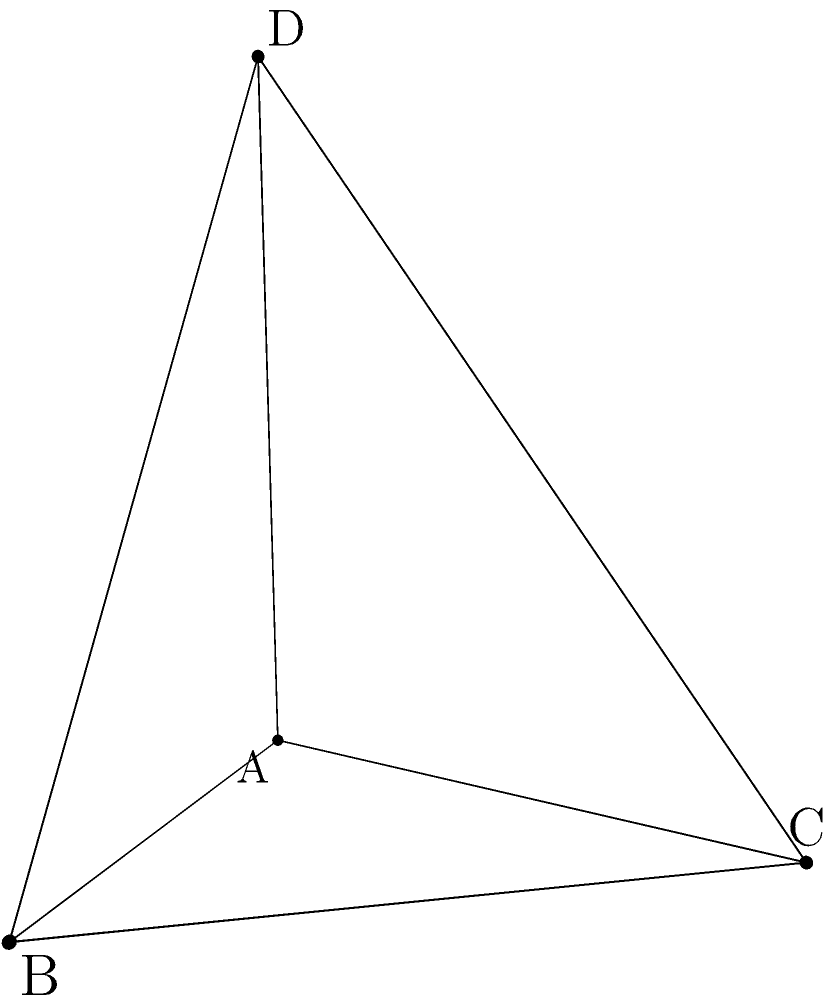Hey there! Remember those challenging geometry problems we used to solve back in university? Here's one that reminds me of our study sessions. Given a tetrahedron ABCD with vertices A(0,0,0), B(3,0,0), C(0,4,0), and D(0,0,5), calculate its volume. Let's approach this step-by-step:

1) The volume of a tetrahedron can be calculated using the formula:

   $$V = \frac{1}{6}|det(\vec{AB}, \vec{AC}, \vec{AD})|$$

   where $\vec{AB}$, $\vec{AC}$, and $\vec{AD}$ are vectors.

2) Let's find these vectors:
   $\vec{AB} = B - A = (3,0,0) - (0,0,0) = (3,0,0)$
   $\vec{AC} = C - A = (0,4,0) - (0,0,0) = (0,4,0)$
   $\vec{AD} = D - A = (0,0,5) - (0,0,0) = (0,0,5)$

3) Now, let's set up the determinant:

   $$det = \begin{vmatrix} 
   3 & 0 & 0 \\
   0 & 4 & 0 \\
   0 & 0 & 5
   \end{vmatrix}$$

4) Calculate the determinant:
   $det = 3 \cdot 4 \cdot 5 = 60$

5) Finally, apply the volume formula:

   $$V = \frac{1}{6}|60| = 10$$

Therefore, the volume of the tetrahedron is 10 cubic units.
Answer: 10 cubic units 